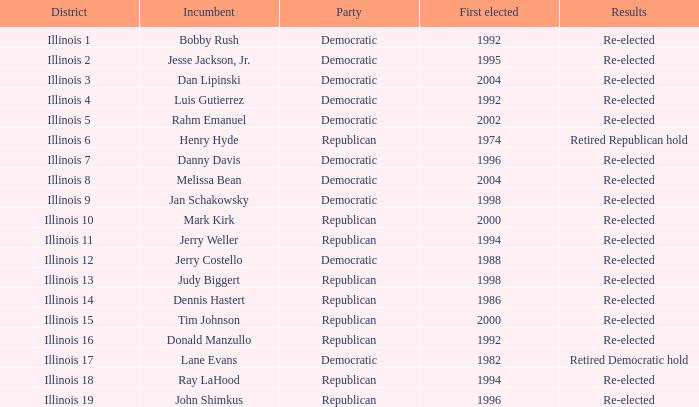When was re-elected incumbent jerry costello initially elected? 1988.0. 